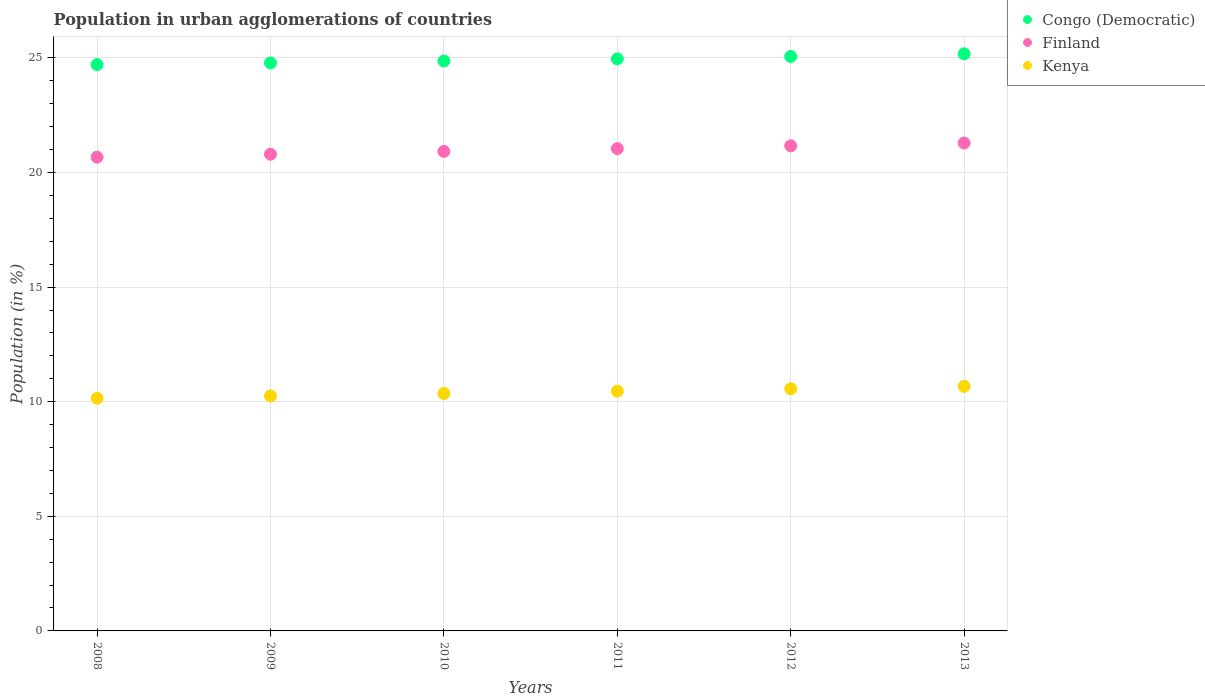How many different coloured dotlines are there?
Ensure brevity in your answer.  3. What is the percentage of population in urban agglomerations in Finland in 2008?
Provide a short and direct response. 20.67. Across all years, what is the maximum percentage of population in urban agglomerations in Kenya?
Your answer should be very brief. 10.67. Across all years, what is the minimum percentage of population in urban agglomerations in Congo (Democratic)?
Your response must be concise. 24.71. In which year was the percentage of population in urban agglomerations in Congo (Democratic) maximum?
Offer a terse response. 2013. In which year was the percentage of population in urban agglomerations in Congo (Democratic) minimum?
Keep it short and to the point. 2008. What is the total percentage of population in urban agglomerations in Kenya in the graph?
Provide a short and direct response. 62.46. What is the difference between the percentage of population in urban agglomerations in Congo (Democratic) in 2008 and that in 2013?
Make the answer very short. -0.47. What is the difference between the percentage of population in urban agglomerations in Kenya in 2009 and the percentage of population in urban agglomerations in Finland in 2012?
Provide a succinct answer. -10.91. What is the average percentage of population in urban agglomerations in Kenya per year?
Provide a short and direct response. 10.41. In the year 2013, what is the difference between the percentage of population in urban agglomerations in Kenya and percentage of population in urban agglomerations in Finland?
Your answer should be compact. -10.62. What is the ratio of the percentage of population in urban agglomerations in Congo (Democratic) in 2008 to that in 2011?
Provide a succinct answer. 0.99. What is the difference between the highest and the second highest percentage of population in urban agglomerations in Congo (Democratic)?
Provide a succinct answer. 0.12. What is the difference between the highest and the lowest percentage of population in urban agglomerations in Congo (Democratic)?
Ensure brevity in your answer.  0.47. In how many years, is the percentage of population in urban agglomerations in Congo (Democratic) greater than the average percentage of population in urban agglomerations in Congo (Democratic) taken over all years?
Offer a terse response. 3. Is it the case that in every year, the sum of the percentage of population in urban agglomerations in Finland and percentage of population in urban agglomerations in Kenya  is greater than the percentage of population in urban agglomerations in Congo (Democratic)?
Keep it short and to the point. Yes. Is the percentage of population in urban agglomerations in Congo (Democratic) strictly less than the percentage of population in urban agglomerations in Finland over the years?
Provide a short and direct response. No. How many dotlines are there?
Your answer should be compact. 3. What is the difference between two consecutive major ticks on the Y-axis?
Your answer should be compact. 5. Are the values on the major ticks of Y-axis written in scientific E-notation?
Give a very brief answer. No. Does the graph contain any zero values?
Your answer should be very brief. No. Does the graph contain grids?
Offer a very short reply. Yes. What is the title of the graph?
Make the answer very short. Population in urban agglomerations of countries. What is the label or title of the X-axis?
Offer a very short reply. Years. What is the label or title of the Y-axis?
Make the answer very short. Population (in %). What is the Population (in %) in Congo (Democratic) in 2008?
Ensure brevity in your answer.  24.71. What is the Population (in %) in Finland in 2008?
Your answer should be very brief. 20.67. What is the Population (in %) in Kenya in 2008?
Make the answer very short. 10.15. What is the Population (in %) of Congo (Democratic) in 2009?
Give a very brief answer. 24.78. What is the Population (in %) in Finland in 2009?
Offer a terse response. 20.8. What is the Population (in %) of Kenya in 2009?
Make the answer very short. 10.25. What is the Population (in %) of Congo (Democratic) in 2010?
Your response must be concise. 24.86. What is the Population (in %) in Finland in 2010?
Ensure brevity in your answer.  20.92. What is the Population (in %) of Kenya in 2010?
Keep it short and to the point. 10.36. What is the Population (in %) of Congo (Democratic) in 2011?
Offer a terse response. 24.96. What is the Population (in %) of Finland in 2011?
Make the answer very short. 21.04. What is the Population (in %) in Kenya in 2011?
Keep it short and to the point. 10.46. What is the Population (in %) of Congo (Democratic) in 2012?
Provide a short and direct response. 25.06. What is the Population (in %) of Finland in 2012?
Give a very brief answer. 21.16. What is the Population (in %) of Kenya in 2012?
Ensure brevity in your answer.  10.56. What is the Population (in %) of Congo (Democratic) in 2013?
Ensure brevity in your answer.  25.18. What is the Population (in %) in Finland in 2013?
Offer a very short reply. 21.29. What is the Population (in %) of Kenya in 2013?
Give a very brief answer. 10.67. Across all years, what is the maximum Population (in %) of Congo (Democratic)?
Offer a terse response. 25.18. Across all years, what is the maximum Population (in %) of Finland?
Your answer should be very brief. 21.29. Across all years, what is the maximum Population (in %) in Kenya?
Give a very brief answer. 10.67. Across all years, what is the minimum Population (in %) of Congo (Democratic)?
Make the answer very short. 24.71. Across all years, what is the minimum Population (in %) in Finland?
Offer a very short reply. 20.67. Across all years, what is the minimum Population (in %) of Kenya?
Provide a short and direct response. 10.15. What is the total Population (in %) in Congo (Democratic) in the graph?
Make the answer very short. 149.54. What is the total Population (in %) of Finland in the graph?
Your response must be concise. 125.87. What is the total Population (in %) in Kenya in the graph?
Offer a very short reply. 62.46. What is the difference between the Population (in %) of Congo (Democratic) in 2008 and that in 2009?
Give a very brief answer. -0.07. What is the difference between the Population (in %) of Finland in 2008 and that in 2009?
Provide a short and direct response. -0.13. What is the difference between the Population (in %) of Kenya in 2008 and that in 2009?
Provide a succinct answer. -0.1. What is the difference between the Population (in %) in Congo (Democratic) in 2008 and that in 2010?
Provide a short and direct response. -0.16. What is the difference between the Population (in %) of Finland in 2008 and that in 2010?
Your answer should be compact. -0.25. What is the difference between the Population (in %) in Kenya in 2008 and that in 2010?
Offer a terse response. -0.21. What is the difference between the Population (in %) of Congo (Democratic) in 2008 and that in 2011?
Offer a very short reply. -0.25. What is the difference between the Population (in %) in Finland in 2008 and that in 2011?
Give a very brief answer. -0.37. What is the difference between the Population (in %) of Kenya in 2008 and that in 2011?
Give a very brief answer. -0.31. What is the difference between the Population (in %) in Congo (Democratic) in 2008 and that in 2012?
Your response must be concise. -0.35. What is the difference between the Population (in %) of Finland in 2008 and that in 2012?
Offer a terse response. -0.49. What is the difference between the Population (in %) in Kenya in 2008 and that in 2012?
Keep it short and to the point. -0.41. What is the difference between the Population (in %) in Congo (Democratic) in 2008 and that in 2013?
Provide a short and direct response. -0.47. What is the difference between the Population (in %) of Finland in 2008 and that in 2013?
Make the answer very short. -0.62. What is the difference between the Population (in %) in Kenya in 2008 and that in 2013?
Your answer should be very brief. -0.52. What is the difference between the Population (in %) of Congo (Democratic) in 2009 and that in 2010?
Ensure brevity in your answer.  -0.08. What is the difference between the Population (in %) of Finland in 2009 and that in 2010?
Keep it short and to the point. -0.12. What is the difference between the Population (in %) of Kenya in 2009 and that in 2010?
Ensure brevity in your answer.  -0.1. What is the difference between the Population (in %) in Congo (Democratic) in 2009 and that in 2011?
Offer a very short reply. -0.18. What is the difference between the Population (in %) of Finland in 2009 and that in 2011?
Keep it short and to the point. -0.25. What is the difference between the Population (in %) of Kenya in 2009 and that in 2011?
Provide a succinct answer. -0.21. What is the difference between the Population (in %) of Congo (Democratic) in 2009 and that in 2012?
Provide a succinct answer. -0.28. What is the difference between the Population (in %) of Finland in 2009 and that in 2012?
Your response must be concise. -0.37. What is the difference between the Population (in %) of Kenya in 2009 and that in 2012?
Your response must be concise. -0.31. What is the difference between the Population (in %) of Congo (Democratic) in 2009 and that in 2013?
Ensure brevity in your answer.  -0.4. What is the difference between the Population (in %) of Finland in 2009 and that in 2013?
Make the answer very short. -0.49. What is the difference between the Population (in %) in Kenya in 2009 and that in 2013?
Ensure brevity in your answer.  -0.42. What is the difference between the Population (in %) in Congo (Democratic) in 2010 and that in 2011?
Offer a terse response. -0.09. What is the difference between the Population (in %) of Finland in 2010 and that in 2011?
Your answer should be very brief. -0.12. What is the difference between the Population (in %) of Kenya in 2010 and that in 2011?
Offer a terse response. -0.1. What is the difference between the Population (in %) in Congo (Democratic) in 2010 and that in 2012?
Make the answer very short. -0.2. What is the difference between the Population (in %) in Finland in 2010 and that in 2012?
Your response must be concise. -0.24. What is the difference between the Population (in %) in Kenya in 2010 and that in 2012?
Your answer should be very brief. -0.21. What is the difference between the Population (in %) of Congo (Democratic) in 2010 and that in 2013?
Offer a very short reply. -0.32. What is the difference between the Population (in %) of Finland in 2010 and that in 2013?
Offer a very short reply. -0.37. What is the difference between the Population (in %) of Kenya in 2010 and that in 2013?
Provide a short and direct response. -0.31. What is the difference between the Population (in %) in Congo (Democratic) in 2011 and that in 2012?
Offer a terse response. -0.11. What is the difference between the Population (in %) of Finland in 2011 and that in 2012?
Keep it short and to the point. -0.12. What is the difference between the Population (in %) in Kenya in 2011 and that in 2012?
Your answer should be very brief. -0.1. What is the difference between the Population (in %) in Congo (Democratic) in 2011 and that in 2013?
Offer a very short reply. -0.22. What is the difference between the Population (in %) of Finland in 2011 and that in 2013?
Your answer should be very brief. -0.24. What is the difference between the Population (in %) of Kenya in 2011 and that in 2013?
Give a very brief answer. -0.21. What is the difference between the Population (in %) of Congo (Democratic) in 2012 and that in 2013?
Offer a very short reply. -0.12. What is the difference between the Population (in %) of Finland in 2012 and that in 2013?
Your answer should be very brief. -0.12. What is the difference between the Population (in %) in Kenya in 2012 and that in 2013?
Offer a terse response. -0.11. What is the difference between the Population (in %) of Congo (Democratic) in 2008 and the Population (in %) of Finland in 2009?
Offer a very short reply. 3.91. What is the difference between the Population (in %) of Congo (Democratic) in 2008 and the Population (in %) of Kenya in 2009?
Make the answer very short. 14.45. What is the difference between the Population (in %) in Finland in 2008 and the Population (in %) in Kenya in 2009?
Give a very brief answer. 10.41. What is the difference between the Population (in %) of Congo (Democratic) in 2008 and the Population (in %) of Finland in 2010?
Ensure brevity in your answer.  3.79. What is the difference between the Population (in %) in Congo (Democratic) in 2008 and the Population (in %) in Kenya in 2010?
Keep it short and to the point. 14.35. What is the difference between the Population (in %) in Finland in 2008 and the Population (in %) in Kenya in 2010?
Ensure brevity in your answer.  10.31. What is the difference between the Population (in %) in Congo (Democratic) in 2008 and the Population (in %) in Finland in 2011?
Ensure brevity in your answer.  3.66. What is the difference between the Population (in %) of Congo (Democratic) in 2008 and the Population (in %) of Kenya in 2011?
Provide a succinct answer. 14.25. What is the difference between the Population (in %) in Finland in 2008 and the Population (in %) in Kenya in 2011?
Your response must be concise. 10.21. What is the difference between the Population (in %) of Congo (Democratic) in 2008 and the Population (in %) of Finland in 2012?
Give a very brief answer. 3.54. What is the difference between the Population (in %) of Congo (Democratic) in 2008 and the Population (in %) of Kenya in 2012?
Provide a succinct answer. 14.14. What is the difference between the Population (in %) of Finland in 2008 and the Population (in %) of Kenya in 2012?
Make the answer very short. 10.1. What is the difference between the Population (in %) in Congo (Democratic) in 2008 and the Population (in %) in Finland in 2013?
Ensure brevity in your answer.  3.42. What is the difference between the Population (in %) of Congo (Democratic) in 2008 and the Population (in %) of Kenya in 2013?
Give a very brief answer. 14.04. What is the difference between the Population (in %) of Finland in 2008 and the Population (in %) of Kenya in 2013?
Offer a terse response. 10. What is the difference between the Population (in %) of Congo (Democratic) in 2009 and the Population (in %) of Finland in 2010?
Offer a terse response. 3.86. What is the difference between the Population (in %) in Congo (Democratic) in 2009 and the Population (in %) in Kenya in 2010?
Your answer should be very brief. 14.42. What is the difference between the Population (in %) in Finland in 2009 and the Population (in %) in Kenya in 2010?
Your answer should be compact. 10.44. What is the difference between the Population (in %) in Congo (Democratic) in 2009 and the Population (in %) in Finland in 2011?
Give a very brief answer. 3.74. What is the difference between the Population (in %) of Congo (Democratic) in 2009 and the Population (in %) of Kenya in 2011?
Give a very brief answer. 14.32. What is the difference between the Population (in %) of Finland in 2009 and the Population (in %) of Kenya in 2011?
Provide a succinct answer. 10.34. What is the difference between the Population (in %) in Congo (Democratic) in 2009 and the Population (in %) in Finland in 2012?
Give a very brief answer. 3.62. What is the difference between the Population (in %) in Congo (Democratic) in 2009 and the Population (in %) in Kenya in 2012?
Your response must be concise. 14.21. What is the difference between the Population (in %) of Finland in 2009 and the Population (in %) of Kenya in 2012?
Ensure brevity in your answer.  10.23. What is the difference between the Population (in %) of Congo (Democratic) in 2009 and the Population (in %) of Finland in 2013?
Keep it short and to the point. 3.49. What is the difference between the Population (in %) of Congo (Democratic) in 2009 and the Population (in %) of Kenya in 2013?
Offer a very short reply. 14.11. What is the difference between the Population (in %) in Finland in 2009 and the Population (in %) in Kenya in 2013?
Ensure brevity in your answer.  10.13. What is the difference between the Population (in %) in Congo (Democratic) in 2010 and the Population (in %) in Finland in 2011?
Offer a terse response. 3.82. What is the difference between the Population (in %) of Congo (Democratic) in 2010 and the Population (in %) of Kenya in 2011?
Your answer should be very brief. 14.4. What is the difference between the Population (in %) of Finland in 2010 and the Population (in %) of Kenya in 2011?
Provide a succinct answer. 10.46. What is the difference between the Population (in %) of Congo (Democratic) in 2010 and the Population (in %) of Finland in 2012?
Offer a very short reply. 3.7. What is the difference between the Population (in %) in Congo (Democratic) in 2010 and the Population (in %) in Kenya in 2012?
Make the answer very short. 14.3. What is the difference between the Population (in %) of Finland in 2010 and the Population (in %) of Kenya in 2012?
Make the answer very short. 10.35. What is the difference between the Population (in %) in Congo (Democratic) in 2010 and the Population (in %) in Finland in 2013?
Provide a short and direct response. 3.58. What is the difference between the Population (in %) of Congo (Democratic) in 2010 and the Population (in %) of Kenya in 2013?
Keep it short and to the point. 14.19. What is the difference between the Population (in %) of Finland in 2010 and the Population (in %) of Kenya in 2013?
Make the answer very short. 10.25. What is the difference between the Population (in %) in Congo (Democratic) in 2011 and the Population (in %) in Finland in 2012?
Your response must be concise. 3.79. What is the difference between the Population (in %) in Congo (Democratic) in 2011 and the Population (in %) in Kenya in 2012?
Provide a succinct answer. 14.39. What is the difference between the Population (in %) in Finland in 2011 and the Population (in %) in Kenya in 2012?
Your answer should be compact. 10.48. What is the difference between the Population (in %) of Congo (Democratic) in 2011 and the Population (in %) of Finland in 2013?
Give a very brief answer. 3.67. What is the difference between the Population (in %) of Congo (Democratic) in 2011 and the Population (in %) of Kenya in 2013?
Your answer should be compact. 14.29. What is the difference between the Population (in %) in Finland in 2011 and the Population (in %) in Kenya in 2013?
Offer a very short reply. 10.37. What is the difference between the Population (in %) in Congo (Democratic) in 2012 and the Population (in %) in Finland in 2013?
Offer a very short reply. 3.77. What is the difference between the Population (in %) of Congo (Democratic) in 2012 and the Population (in %) of Kenya in 2013?
Your response must be concise. 14.39. What is the difference between the Population (in %) of Finland in 2012 and the Population (in %) of Kenya in 2013?
Your answer should be compact. 10.49. What is the average Population (in %) in Congo (Democratic) per year?
Provide a succinct answer. 24.92. What is the average Population (in %) of Finland per year?
Keep it short and to the point. 20.98. What is the average Population (in %) of Kenya per year?
Give a very brief answer. 10.41. In the year 2008, what is the difference between the Population (in %) in Congo (Democratic) and Population (in %) in Finland?
Provide a succinct answer. 4.04. In the year 2008, what is the difference between the Population (in %) of Congo (Democratic) and Population (in %) of Kenya?
Your answer should be compact. 14.55. In the year 2008, what is the difference between the Population (in %) in Finland and Population (in %) in Kenya?
Make the answer very short. 10.52. In the year 2009, what is the difference between the Population (in %) in Congo (Democratic) and Population (in %) in Finland?
Ensure brevity in your answer.  3.98. In the year 2009, what is the difference between the Population (in %) in Congo (Democratic) and Population (in %) in Kenya?
Make the answer very short. 14.52. In the year 2009, what is the difference between the Population (in %) in Finland and Population (in %) in Kenya?
Your answer should be very brief. 10.54. In the year 2010, what is the difference between the Population (in %) of Congo (Democratic) and Population (in %) of Finland?
Provide a short and direct response. 3.94. In the year 2010, what is the difference between the Population (in %) in Congo (Democratic) and Population (in %) in Kenya?
Ensure brevity in your answer.  14.5. In the year 2010, what is the difference between the Population (in %) of Finland and Population (in %) of Kenya?
Provide a succinct answer. 10.56. In the year 2011, what is the difference between the Population (in %) in Congo (Democratic) and Population (in %) in Finland?
Provide a succinct answer. 3.91. In the year 2011, what is the difference between the Population (in %) in Congo (Democratic) and Population (in %) in Kenya?
Your answer should be compact. 14.49. In the year 2011, what is the difference between the Population (in %) in Finland and Population (in %) in Kenya?
Offer a terse response. 10.58. In the year 2012, what is the difference between the Population (in %) of Congo (Democratic) and Population (in %) of Finland?
Your response must be concise. 3.9. In the year 2012, what is the difference between the Population (in %) in Congo (Democratic) and Population (in %) in Kenya?
Your answer should be compact. 14.5. In the year 2012, what is the difference between the Population (in %) of Finland and Population (in %) of Kenya?
Your answer should be compact. 10.6. In the year 2013, what is the difference between the Population (in %) in Congo (Democratic) and Population (in %) in Finland?
Offer a terse response. 3.89. In the year 2013, what is the difference between the Population (in %) of Congo (Democratic) and Population (in %) of Kenya?
Offer a terse response. 14.51. In the year 2013, what is the difference between the Population (in %) in Finland and Population (in %) in Kenya?
Give a very brief answer. 10.62. What is the ratio of the Population (in %) in Congo (Democratic) in 2008 to that in 2010?
Ensure brevity in your answer.  0.99. What is the ratio of the Population (in %) in Kenya in 2008 to that in 2010?
Give a very brief answer. 0.98. What is the ratio of the Population (in %) of Finland in 2008 to that in 2011?
Your answer should be very brief. 0.98. What is the ratio of the Population (in %) of Kenya in 2008 to that in 2011?
Offer a very short reply. 0.97. What is the ratio of the Population (in %) in Congo (Democratic) in 2008 to that in 2012?
Keep it short and to the point. 0.99. What is the ratio of the Population (in %) in Finland in 2008 to that in 2012?
Your response must be concise. 0.98. What is the ratio of the Population (in %) in Kenya in 2008 to that in 2012?
Offer a very short reply. 0.96. What is the ratio of the Population (in %) of Congo (Democratic) in 2008 to that in 2013?
Offer a very short reply. 0.98. What is the ratio of the Population (in %) of Finland in 2008 to that in 2013?
Make the answer very short. 0.97. What is the ratio of the Population (in %) in Kenya in 2008 to that in 2013?
Your response must be concise. 0.95. What is the ratio of the Population (in %) in Kenya in 2009 to that in 2010?
Your answer should be compact. 0.99. What is the ratio of the Population (in %) in Congo (Democratic) in 2009 to that in 2011?
Provide a short and direct response. 0.99. What is the ratio of the Population (in %) of Finland in 2009 to that in 2011?
Your answer should be very brief. 0.99. What is the ratio of the Population (in %) of Kenya in 2009 to that in 2011?
Provide a short and direct response. 0.98. What is the ratio of the Population (in %) of Congo (Democratic) in 2009 to that in 2012?
Make the answer very short. 0.99. What is the ratio of the Population (in %) of Finland in 2009 to that in 2012?
Your answer should be compact. 0.98. What is the ratio of the Population (in %) of Kenya in 2009 to that in 2012?
Offer a terse response. 0.97. What is the ratio of the Population (in %) of Congo (Democratic) in 2009 to that in 2013?
Give a very brief answer. 0.98. What is the ratio of the Population (in %) of Finland in 2009 to that in 2013?
Keep it short and to the point. 0.98. What is the ratio of the Population (in %) of Congo (Democratic) in 2010 to that in 2011?
Give a very brief answer. 1. What is the ratio of the Population (in %) of Kenya in 2010 to that in 2011?
Offer a very short reply. 0.99. What is the ratio of the Population (in %) of Kenya in 2010 to that in 2012?
Provide a short and direct response. 0.98. What is the ratio of the Population (in %) of Congo (Democratic) in 2010 to that in 2013?
Keep it short and to the point. 0.99. What is the ratio of the Population (in %) of Finland in 2010 to that in 2013?
Provide a succinct answer. 0.98. What is the ratio of the Population (in %) in Kenya in 2010 to that in 2013?
Give a very brief answer. 0.97. What is the ratio of the Population (in %) of Finland in 2011 to that in 2012?
Offer a terse response. 0.99. What is the ratio of the Population (in %) of Kenya in 2011 to that in 2012?
Offer a terse response. 0.99. What is the ratio of the Population (in %) in Finland in 2011 to that in 2013?
Provide a short and direct response. 0.99. What is the ratio of the Population (in %) in Kenya in 2011 to that in 2013?
Make the answer very short. 0.98. What is the difference between the highest and the second highest Population (in %) in Congo (Democratic)?
Provide a short and direct response. 0.12. What is the difference between the highest and the second highest Population (in %) in Finland?
Offer a terse response. 0.12. What is the difference between the highest and the second highest Population (in %) in Kenya?
Offer a terse response. 0.11. What is the difference between the highest and the lowest Population (in %) in Congo (Democratic)?
Provide a short and direct response. 0.47. What is the difference between the highest and the lowest Population (in %) of Finland?
Provide a short and direct response. 0.62. What is the difference between the highest and the lowest Population (in %) in Kenya?
Offer a very short reply. 0.52. 